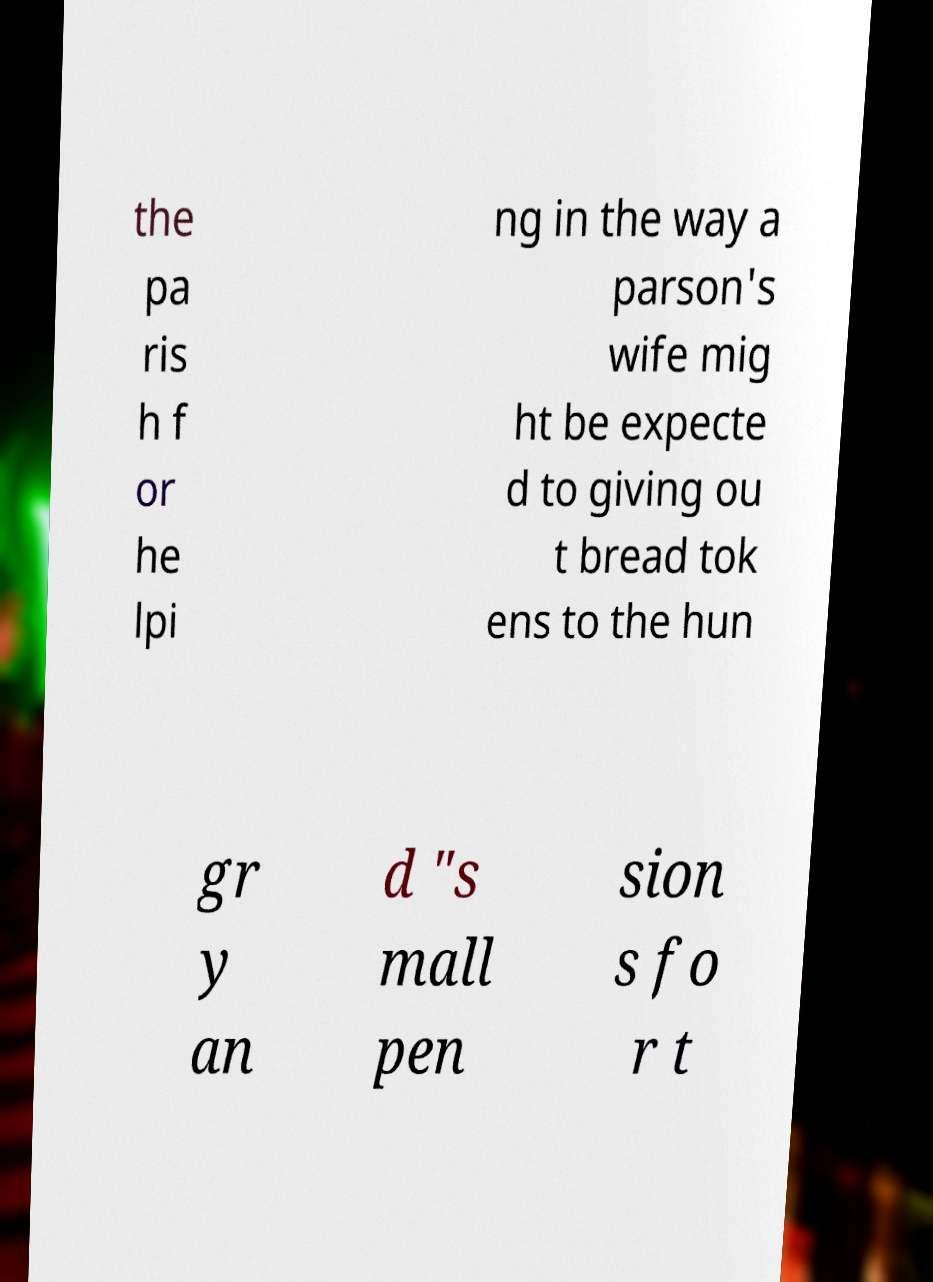Could you extract and type out the text from this image? the pa ris h f or he lpi ng in the way a parson's wife mig ht be expecte d to giving ou t bread tok ens to the hun gr y an d "s mall pen sion s fo r t 